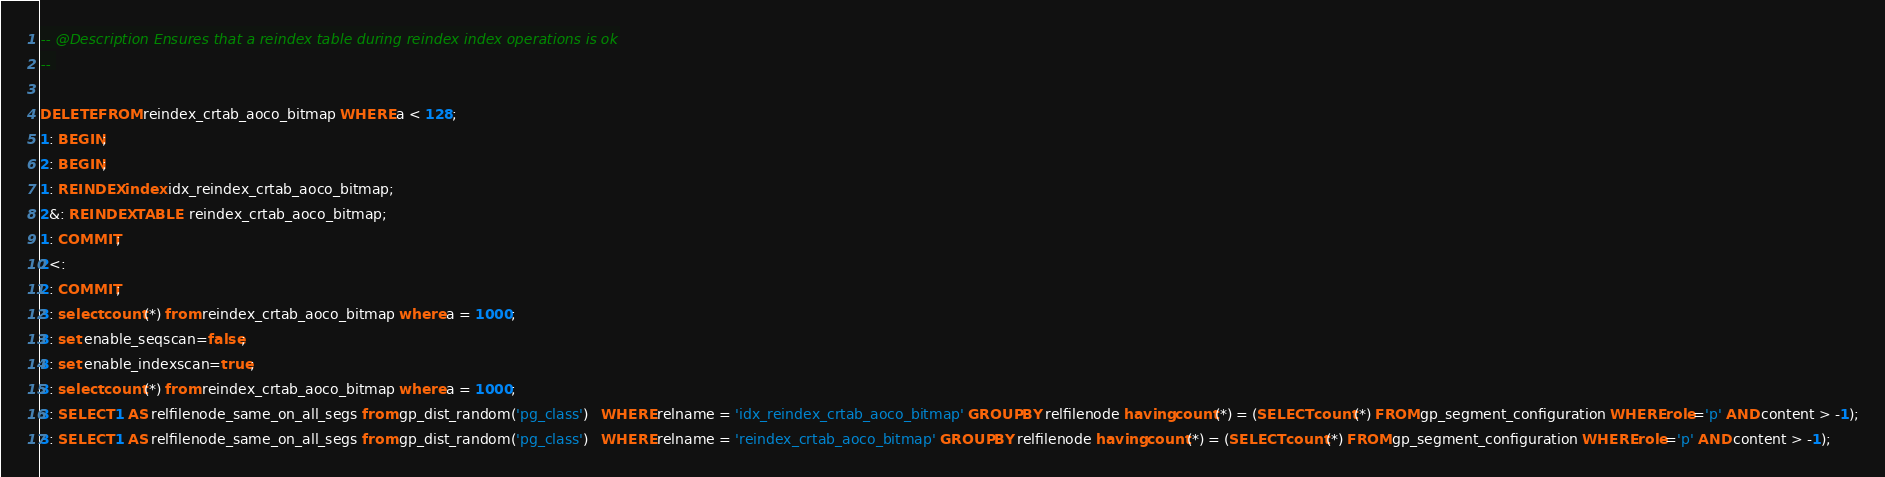Convert code to text. <code><loc_0><loc_0><loc_500><loc_500><_SQL_>-- @Description Ensures that a reindex table during reindex index operations is ok
-- 

DELETE FROM reindex_crtab_aoco_bitmap WHERE a < 128;
1: BEGIN;
2: BEGIN;
1: REINDEX index idx_reindex_crtab_aoco_bitmap;
2&: REINDEX TABLE  reindex_crtab_aoco_bitmap;
1: COMMIT;
2<:
2: COMMIT;
3: select count(*) from reindex_crtab_aoco_bitmap where a = 1000;
3: set enable_seqscan=false;
3: set enable_indexscan=true;
3: select count(*) from reindex_crtab_aoco_bitmap where a = 1000;
3: SELECT 1 AS relfilenode_same_on_all_segs from gp_dist_random('pg_class')   WHERE relname = 'idx_reindex_crtab_aoco_bitmap' GROUP BY relfilenode having count(*) = (SELECT count(*) FROM gp_segment_configuration WHERE role='p' AND content > -1);
3: SELECT 1 AS relfilenode_same_on_all_segs from gp_dist_random('pg_class')   WHERE relname = 'reindex_crtab_aoco_bitmap' GROUP BY relfilenode having count(*) = (SELECT count(*) FROM gp_segment_configuration WHERE role='p' AND content > -1);

</code> 